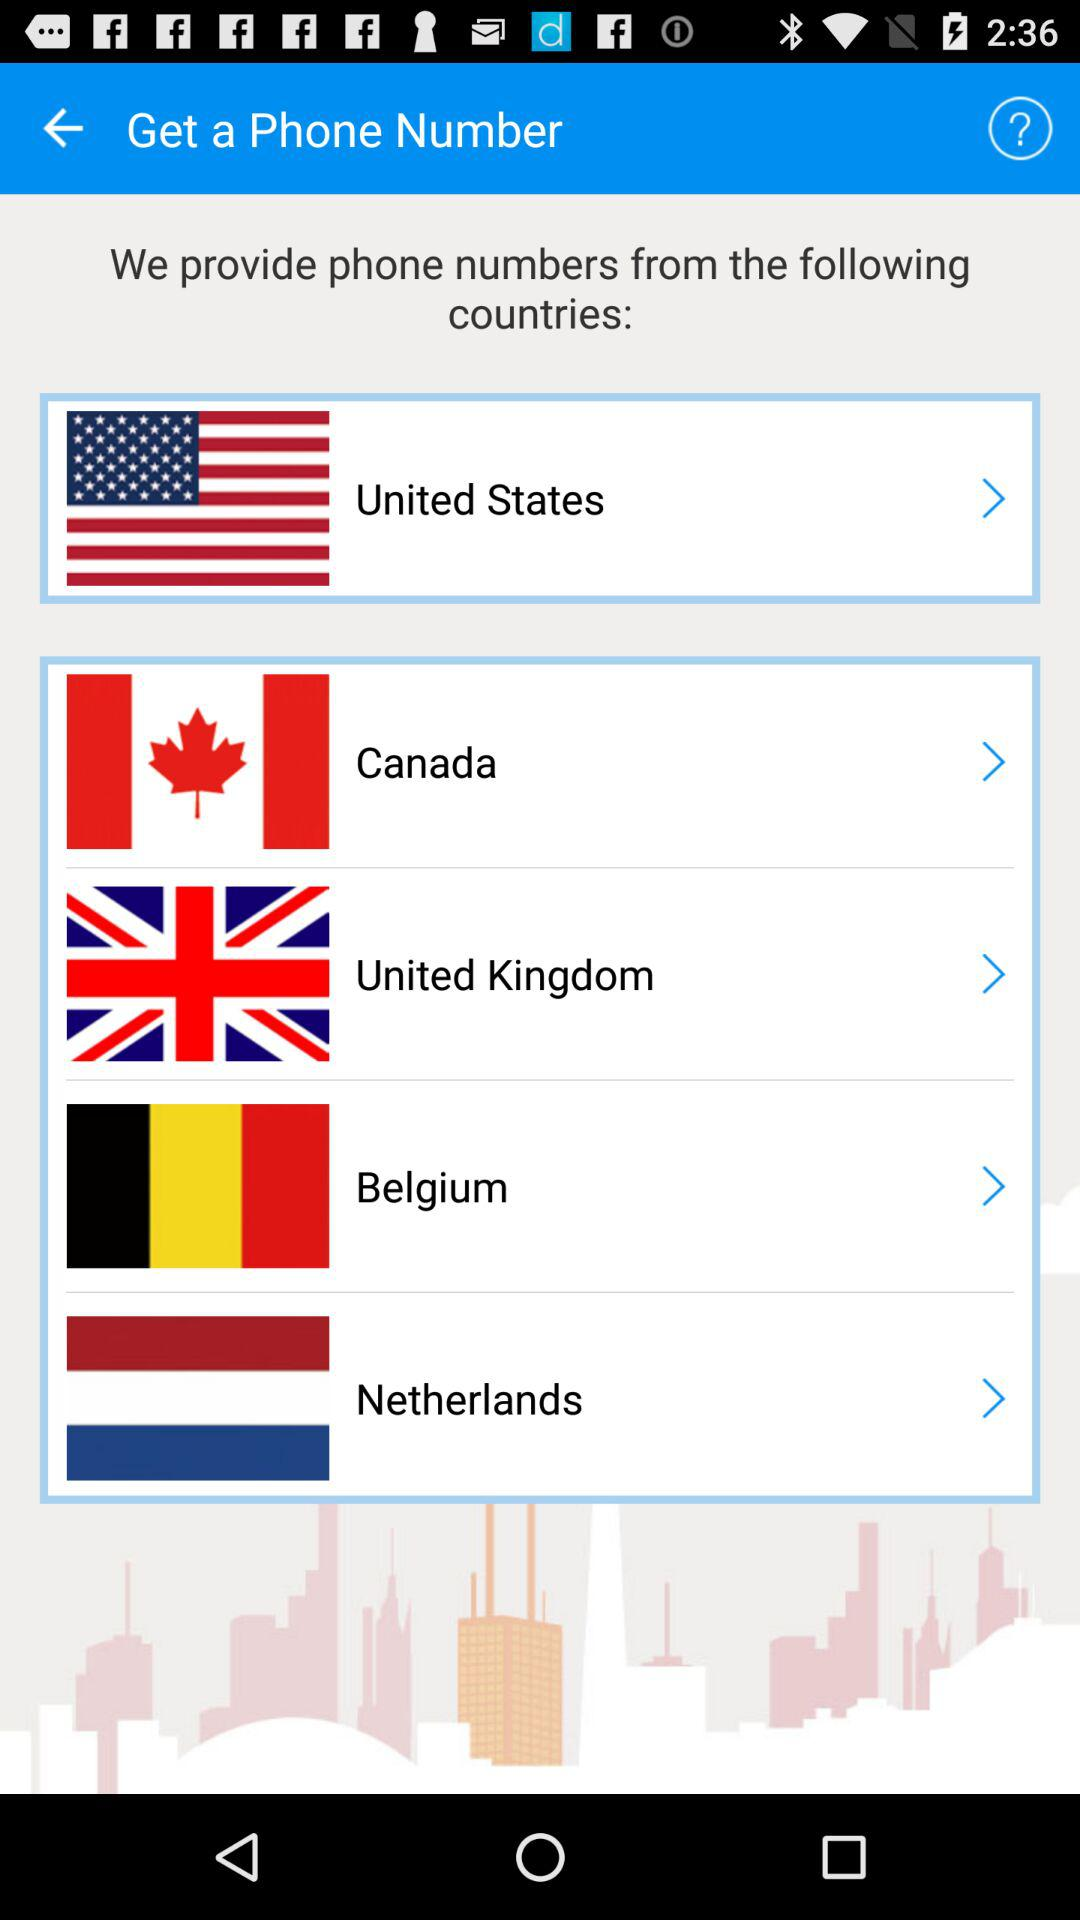How many countries have phone numbers available?
Answer the question using a single word or phrase. 5 